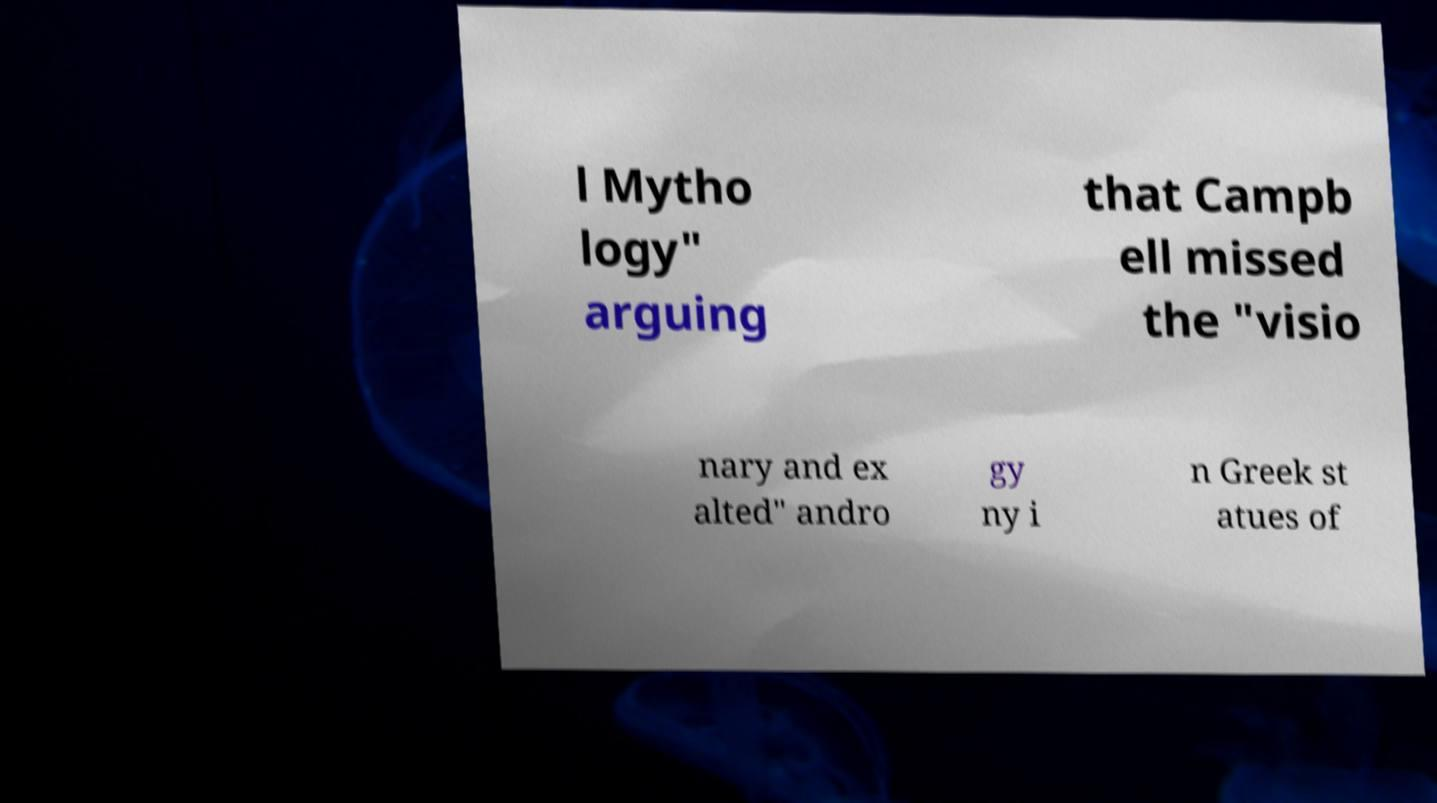There's text embedded in this image that I need extracted. Can you transcribe it verbatim? l Mytho logy" arguing that Campb ell missed the "visio nary and ex alted" andro gy ny i n Greek st atues of 